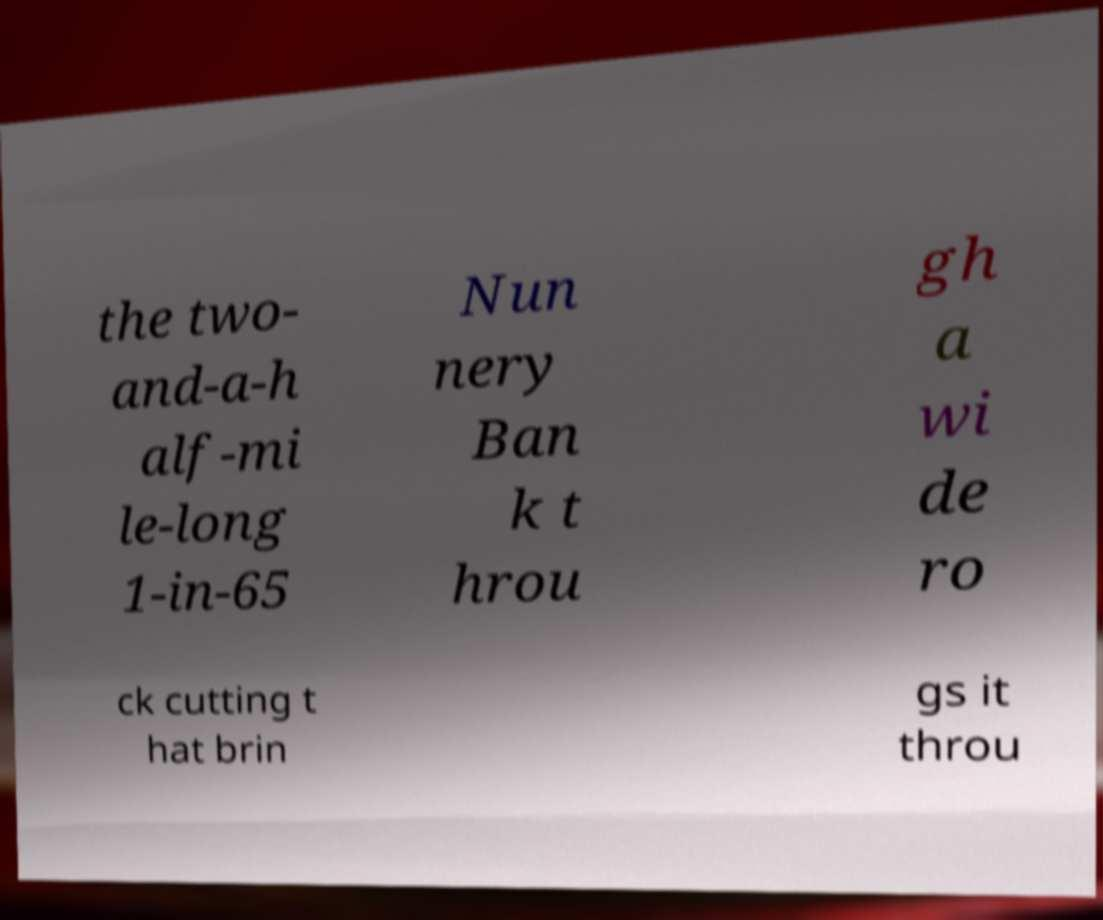Can you read and provide the text displayed in the image?This photo seems to have some interesting text. Can you extract and type it out for me? the two- and-a-h alf-mi le-long 1-in-65 Nun nery Ban k t hrou gh a wi de ro ck cutting t hat brin gs it throu 